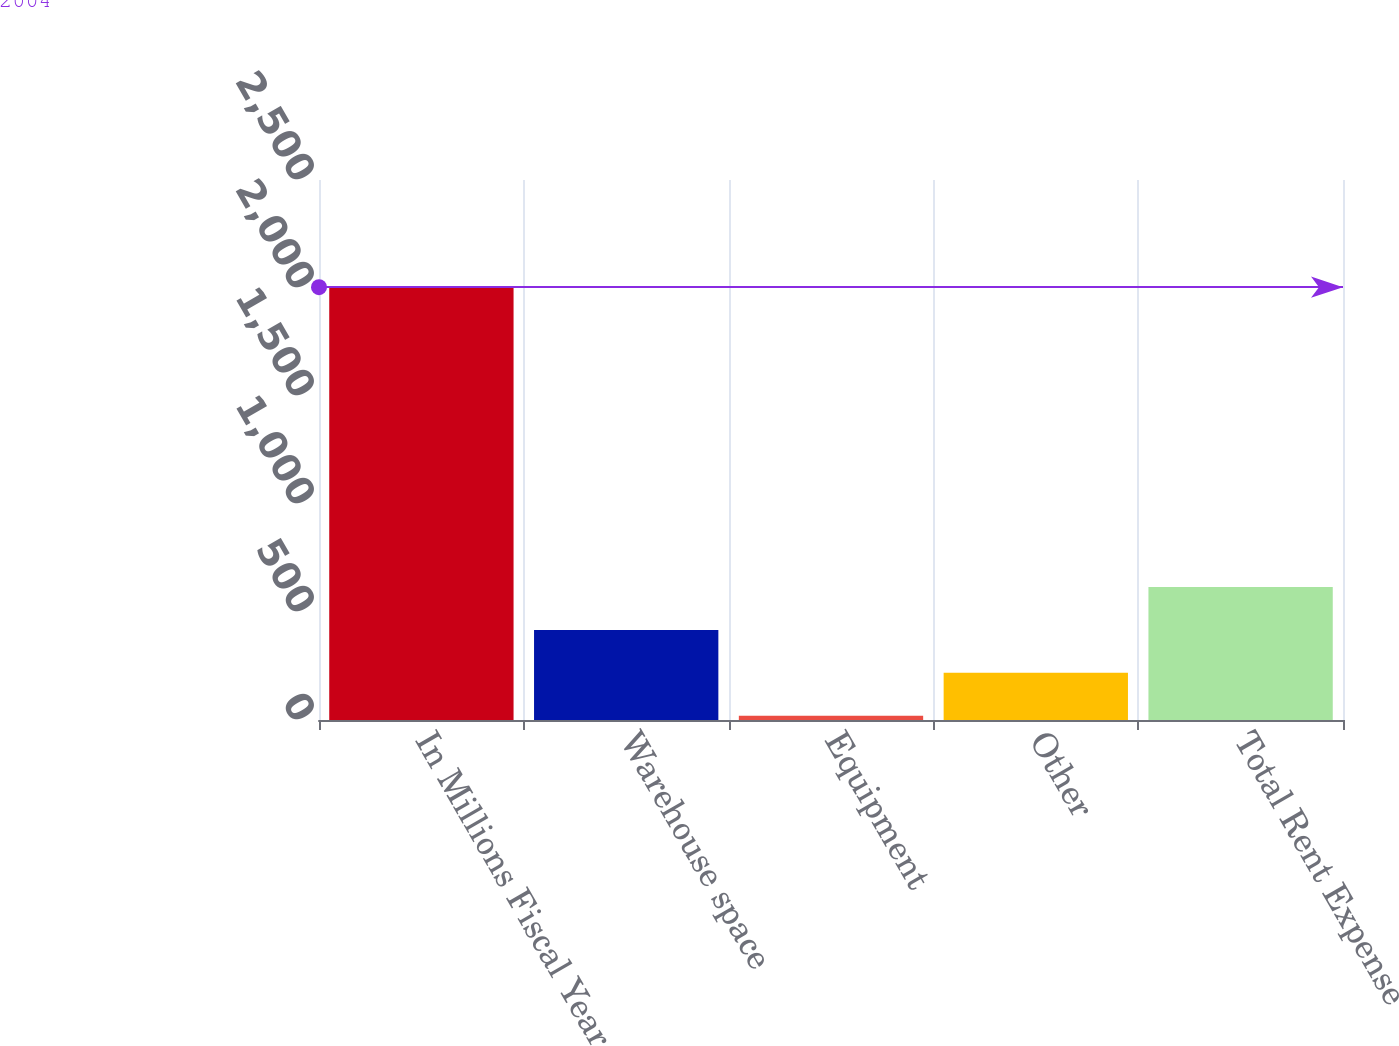Convert chart. <chart><loc_0><loc_0><loc_500><loc_500><bar_chart><fcel>In Millions Fiscal Year<fcel>Warehouse space<fcel>Equipment<fcel>Other<fcel>Total Rent Expense<nl><fcel>2004<fcel>416.8<fcel>20<fcel>218.4<fcel>615.2<nl></chart> 